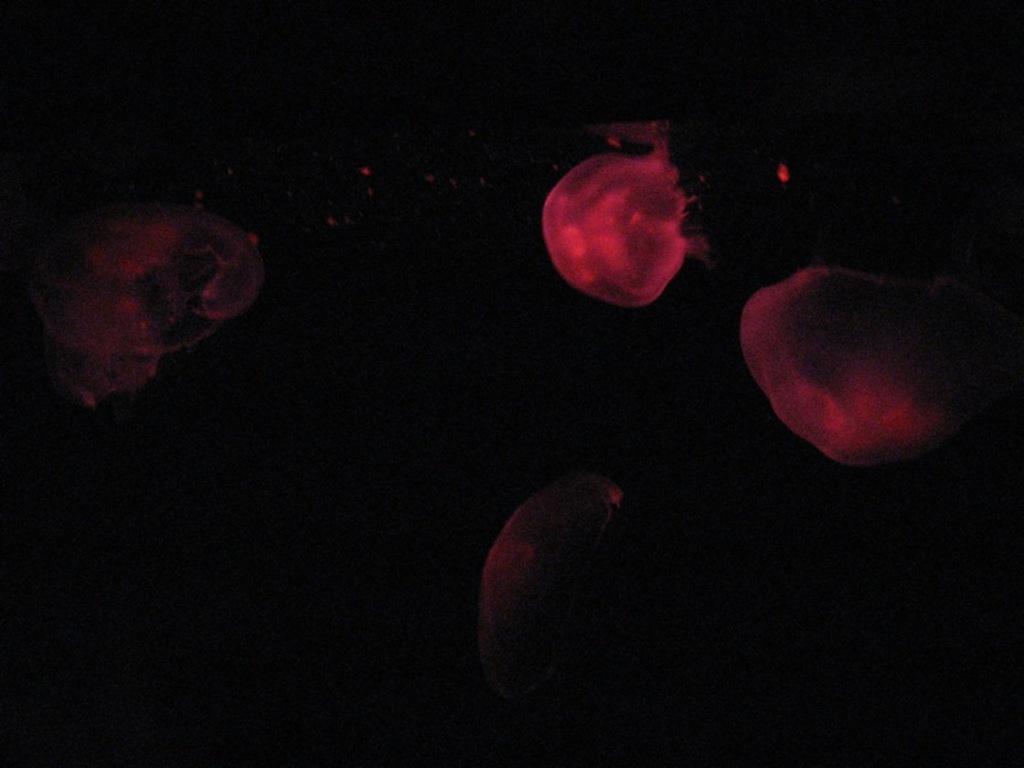How would you summarize this image in a sentence or two? In this picture, we see the jellyfishes or the blood cells in red color. In the background, it is black in color. This picture is blurred in the background. 